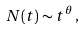<formula> <loc_0><loc_0><loc_500><loc_500>N ( t ) \sim t ^ { \theta } \, ,</formula> 